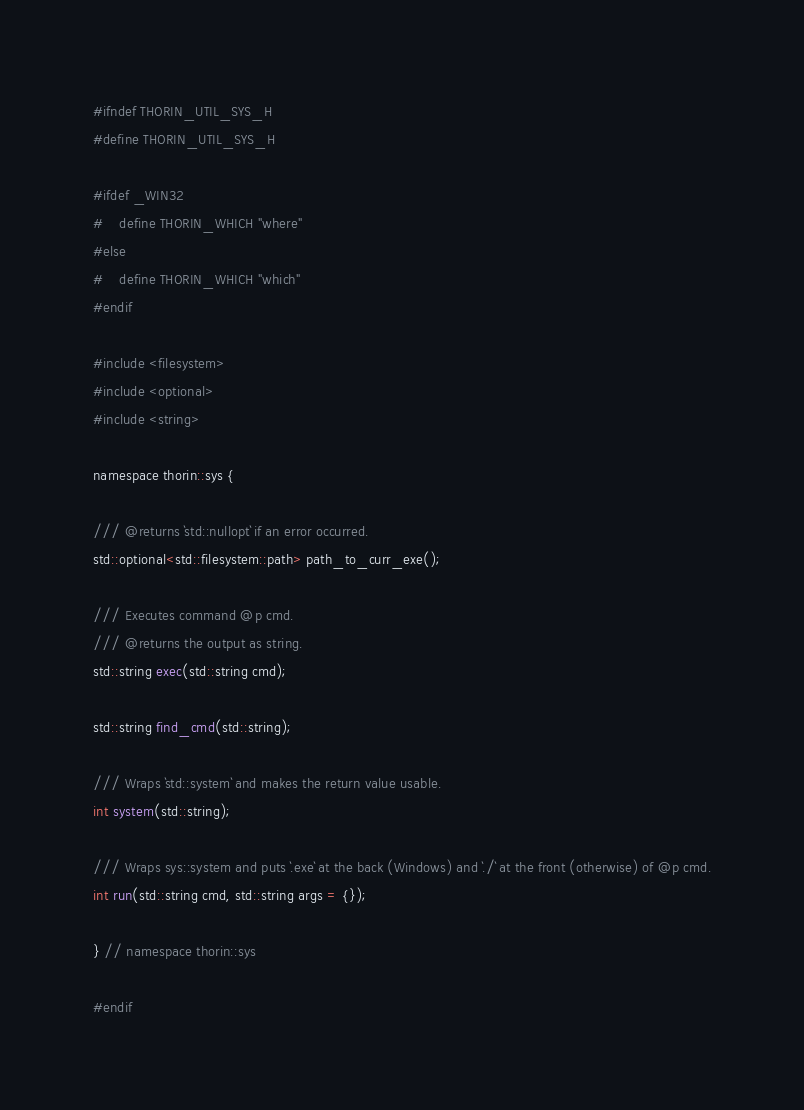Convert code to text. <code><loc_0><loc_0><loc_500><loc_500><_C_>#ifndef THORIN_UTIL_SYS_H
#define THORIN_UTIL_SYS_H

#ifdef _WIN32
#    define THORIN_WHICH "where"
#else
#    define THORIN_WHICH "which"
#endif

#include <filesystem>
#include <optional>
#include <string>

namespace thorin::sys {

/// @returns `std::nullopt` if an error occurred.
std::optional<std::filesystem::path> path_to_curr_exe();

/// Executes command @p cmd.
/// @returns the output as string.
std::string exec(std::string cmd);

std::string find_cmd(std::string);

/// Wraps `std::system` and makes the return value usable.
int system(std::string);

/// Wraps sys::system and puts `.exe` at the back (Windows) and `./` at the front (otherwise) of @p cmd.
int run(std::string cmd, std::string args = {});

} // namespace thorin::sys

#endif
</code> 